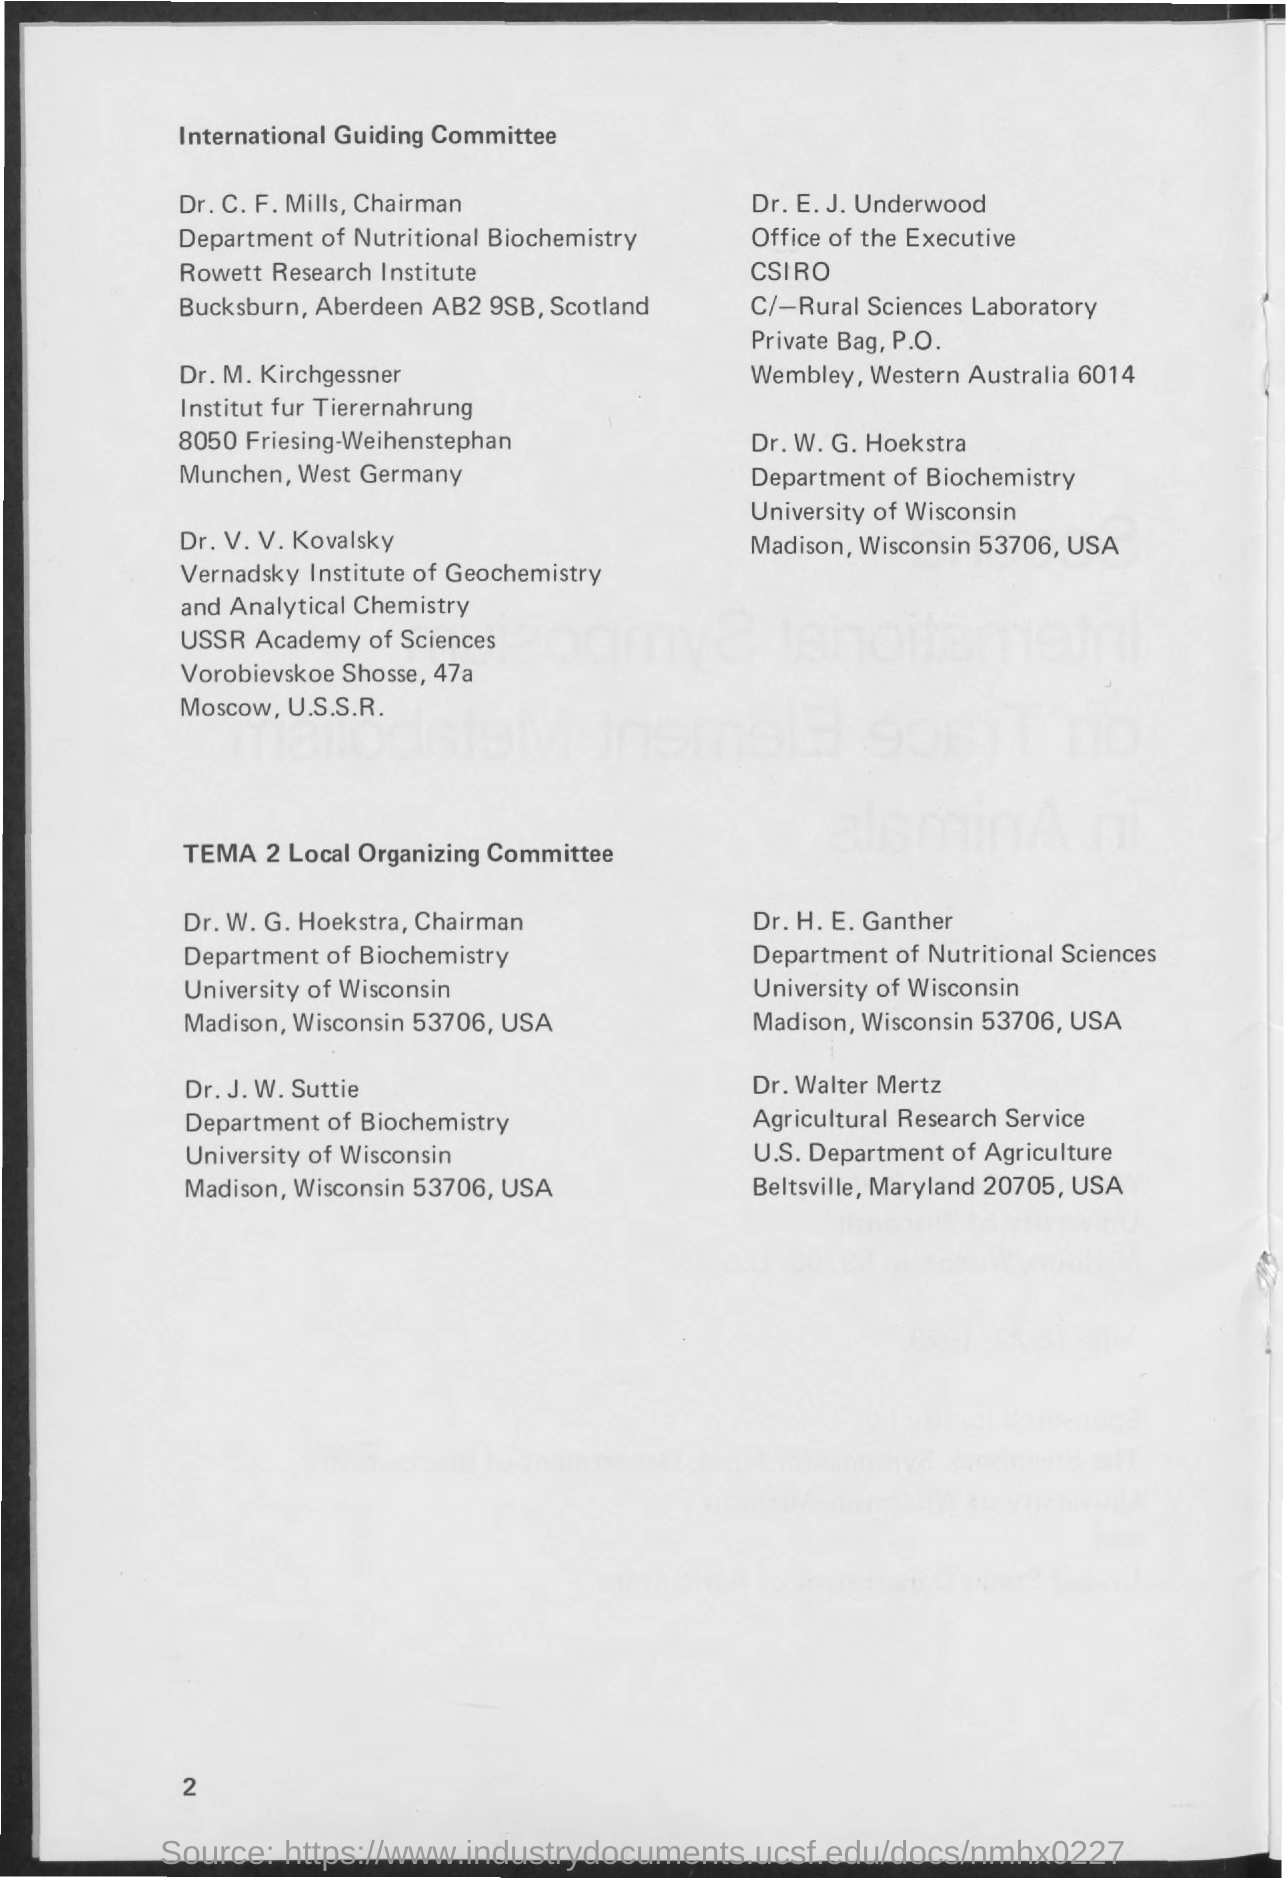Give some essential details in this illustration. Dr. E. J. Underwood is a member of the International Guiding Committee, which is located in Australia. Dr. Walter Mertz is a member of 'TEMA 2 Local Organizing Committee' based in Maryland, USA. The member of the International Guiding Committee from Scotland is Dr. C. F. Mills. Dr. W. G. Hoekstra is a member of the International Guiding Committee, which is located in the USA. 